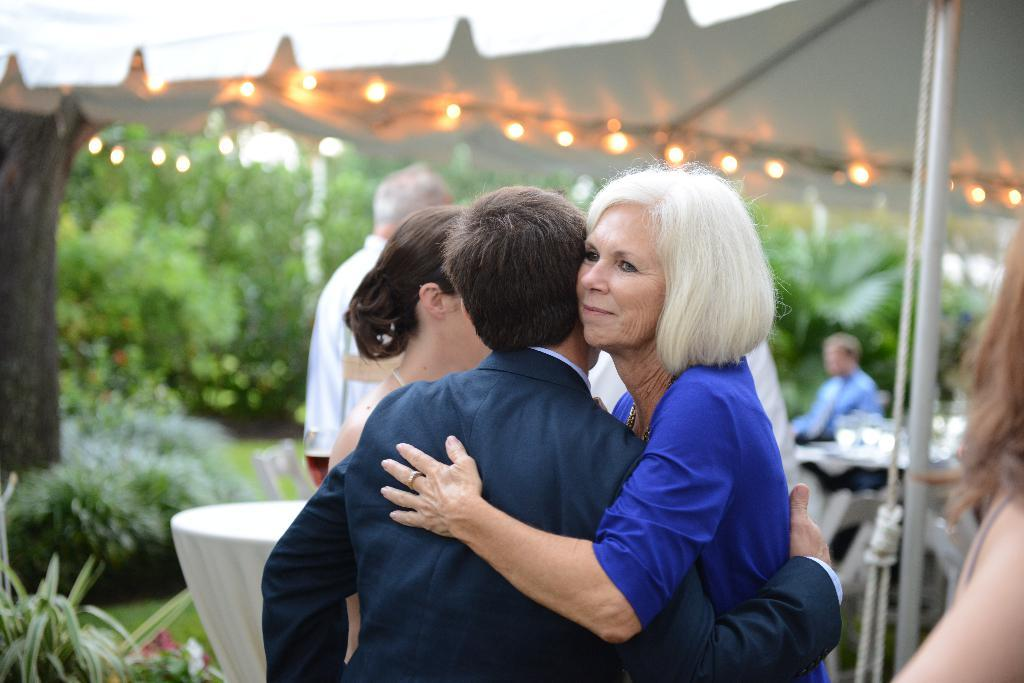Who or what can be seen in the image? There are people in the image. What can be observed in the image that provides illumination? There are lights in the image. What type of vegetation is present in the image? There are plants in the image. What type of furniture is visible in the image? There are tables in the image. What type of structure is present in the image for displaying or holding items? There are stands in the image. What type of wool is being used by the people in the image? There is no wool present in the image; it does not mention or show any wool-related items or activities. 